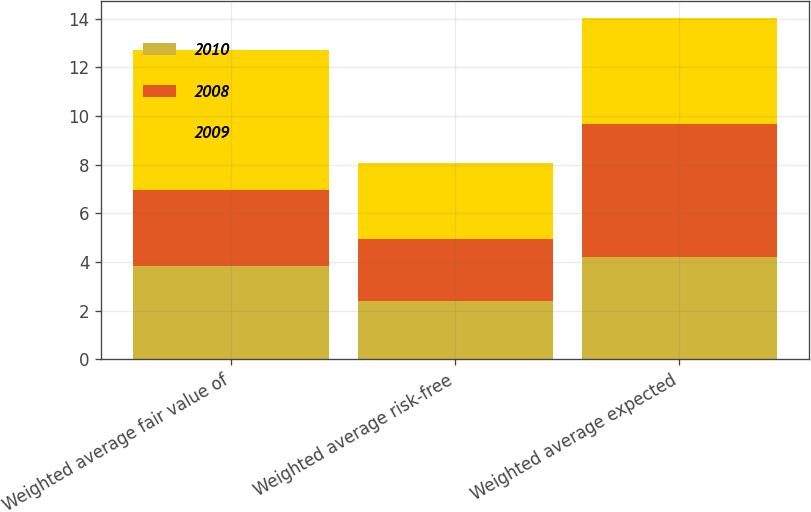Convert chart. <chart><loc_0><loc_0><loc_500><loc_500><stacked_bar_chart><ecel><fcel>Weighted average fair value of<fcel>Weighted average risk-free<fcel>Weighted average expected<nl><fcel>2010<fcel>3.82<fcel>2.4<fcel>4.21<nl><fcel>2008<fcel>3.16<fcel>2.54<fcel>5.48<nl><fcel>2009<fcel>5.73<fcel>3.13<fcel>4.33<nl></chart> 